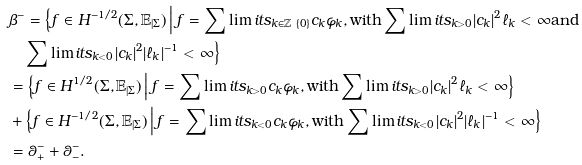<formula> <loc_0><loc_0><loc_500><loc_500>& \beta ^ { - } = \Big \{ f \in H ^ { - 1 / 2 } ( \Sigma , \mathbb { E } _ { | \Sigma } ) \, \Big | \, f = \sum \lim i t s _ { k \in \mathbb { Z } \ \{ 0 \} } c _ { k } \varphi _ { k } , \text {with} \sum \lim i t s _ { k > 0 } | c _ { k } | ^ { 2 } \ell _ { k } < \infty \text {and} \\ & \quad \sum \lim i t s _ { k < 0 } | c _ { k } | ^ { 2 } | \ell _ { k } | ^ { - 1 } < \infty \Big \} \\ & = \Big \{ f \in H ^ { 1 / 2 } ( \Sigma , \mathbb { E } _ { | \Sigma } ) \, \Big | \, f = \sum \lim i t s _ { k > 0 } c _ { k } \varphi _ { k } , \text {with} \sum \lim i t s _ { k > 0 } | c _ { k } | ^ { 2 } \ell _ { k } < \infty \Big \} \\ & + \Big \{ f \in H ^ { - 1 / 2 } ( \Sigma , \mathbb { E } _ { | \Sigma } ) \, \Big | \, f = \sum \lim i t s _ { k < 0 } c _ { k } \varphi _ { k } , \text {with} \sum \lim i t s _ { k < 0 } | c _ { k } | ^ { 2 } | \ell _ { k } | ^ { - 1 } < \infty \Big \} \\ & = \theta ^ { - } _ { + } + \theta ^ { - } _ { - } .</formula> 